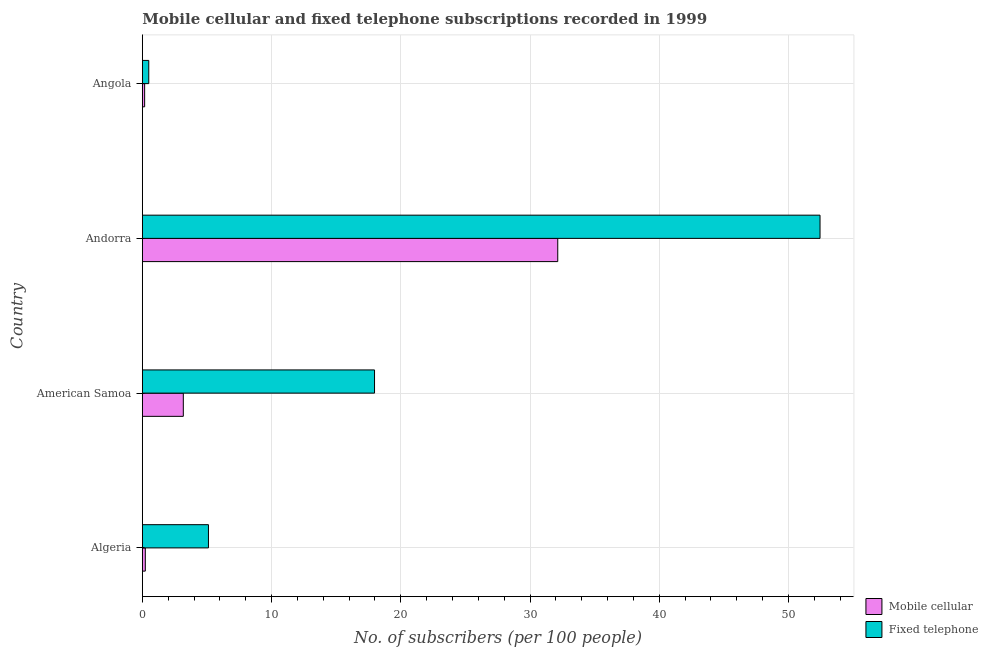How many different coloured bars are there?
Keep it short and to the point. 2. How many groups of bars are there?
Give a very brief answer. 4. Are the number of bars per tick equal to the number of legend labels?
Provide a short and direct response. Yes. Are the number of bars on each tick of the Y-axis equal?
Keep it short and to the point. Yes. How many bars are there on the 3rd tick from the bottom?
Keep it short and to the point. 2. What is the label of the 2nd group of bars from the top?
Ensure brevity in your answer.  Andorra. In how many cases, is the number of bars for a given country not equal to the number of legend labels?
Ensure brevity in your answer.  0. What is the number of mobile cellular subscribers in American Samoa?
Your answer should be very brief. 3.17. Across all countries, what is the maximum number of mobile cellular subscribers?
Your answer should be very brief. 32.15. Across all countries, what is the minimum number of fixed telephone subscribers?
Your answer should be compact. 0.5. In which country was the number of mobile cellular subscribers maximum?
Your answer should be very brief. Andorra. In which country was the number of mobile cellular subscribers minimum?
Provide a succinct answer. Angola. What is the total number of fixed telephone subscribers in the graph?
Offer a terse response. 76.02. What is the difference between the number of mobile cellular subscribers in American Samoa and that in Angola?
Your answer should be compact. 2.99. What is the difference between the number of fixed telephone subscribers in Andorra and the number of mobile cellular subscribers in American Samoa?
Make the answer very short. 49.27. What is the average number of mobile cellular subscribers per country?
Your response must be concise. 8.93. What is the difference between the number of mobile cellular subscribers and number of fixed telephone subscribers in American Samoa?
Keep it short and to the point. -14.8. What is the ratio of the number of fixed telephone subscribers in American Samoa to that in Angola?
Offer a terse response. 36.12. Is the number of mobile cellular subscribers in Algeria less than that in Angola?
Your answer should be compact. No. Is the difference between the number of mobile cellular subscribers in Andorra and Angola greater than the difference between the number of fixed telephone subscribers in Andorra and Angola?
Ensure brevity in your answer.  No. What is the difference between the highest and the second highest number of mobile cellular subscribers?
Provide a succinct answer. 28.98. What is the difference between the highest and the lowest number of mobile cellular subscribers?
Give a very brief answer. 31.97. In how many countries, is the number of mobile cellular subscribers greater than the average number of mobile cellular subscribers taken over all countries?
Keep it short and to the point. 1. What does the 1st bar from the top in Algeria represents?
Your answer should be very brief. Fixed telephone. What does the 1st bar from the bottom in American Samoa represents?
Your response must be concise. Mobile cellular. How many bars are there?
Provide a succinct answer. 8. Are all the bars in the graph horizontal?
Provide a succinct answer. Yes. What is the difference between two consecutive major ticks on the X-axis?
Keep it short and to the point. 10. Where does the legend appear in the graph?
Offer a very short reply. Bottom right. How many legend labels are there?
Provide a short and direct response. 2. How are the legend labels stacked?
Provide a short and direct response. Vertical. What is the title of the graph?
Make the answer very short. Mobile cellular and fixed telephone subscriptions recorded in 1999. What is the label or title of the X-axis?
Offer a terse response. No. of subscribers (per 100 people). What is the label or title of the Y-axis?
Provide a succinct answer. Country. What is the No. of subscribers (per 100 people) in Mobile cellular in Algeria?
Provide a succinct answer. 0.23. What is the No. of subscribers (per 100 people) in Fixed telephone in Algeria?
Provide a succinct answer. 5.12. What is the No. of subscribers (per 100 people) of Mobile cellular in American Samoa?
Your answer should be very brief. 3.17. What is the No. of subscribers (per 100 people) of Fixed telephone in American Samoa?
Provide a succinct answer. 17.97. What is the No. of subscribers (per 100 people) in Mobile cellular in Andorra?
Give a very brief answer. 32.15. What is the No. of subscribers (per 100 people) in Fixed telephone in Andorra?
Provide a short and direct response. 52.44. What is the No. of subscribers (per 100 people) in Mobile cellular in Angola?
Your answer should be compact. 0.18. What is the No. of subscribers (per 100 people) in Fixed telephone in Angola?
Your answer should be compact. 0.5. Across all countries, what is the maximum No. of subscribers (per 100 people) of Mobile cellular?
Your answer should be very brief. 32.15. Across all countries, what is the maximum No. of subscribers (per 100 people) of Fixed telephone?
Provide a succinct answer. 52.44. Across all countries, what is the minimum No. of subscribers (per 100 people) in Mobile cellular?
Offer a very short reply. 0.18. Across all countries, what is the minimum No. of subscribers (per 100 people) of Fixed telephone?
Give a very brief answer. 0.5. What is the total No. of subscribers (per 100 people) of Mobile cellular in the graph?
Keep it short and to the point. 35.72. What is the total No. of subscribers (per 100 people) in Fixed telephone in the graph?
Make the answer very short. 76.02. What is the difference between the No. of subscribers (per 100 people) in Mobile cellular in Algeria and that in American Samoa?
Your answer should be very brief. -2.94. What is the difference between the No. of subscribers (per 100 people) of Fixed telephone in Algeria and that in American Samoa?
Make the answer very short. -12.85. What is the difference between the No. of subscribers (per 100 people) of Mobile cellular in Algeria and that in Andorra?
Your response must be concise. -31.92. What is the difference between the No. of subscribers (per 100 people) in Fixed telephone in Algeria and that in Andorra?
Make the answer very short. -47.33. What is the difference between the No. of subscribers (per 100 people) of Mobile cellular in Algeria and that in Angola?
Provide a short and direct response. 0.05. What is the difference between the No. of subscribers (per 100 people) in Fixed telephone in Algeria and that in Angola?
Provide a short and direct response. 4.62. What is the difference between the No. of subscribers (per 100 people) of Mobile cellular in American Samoa and that in Andorra?
Make the answer very short. -28.97. What is the difference between the No. of subscribers (per 100 people) of Fixed telephone in American Samoa and that in Andorra?
Give a very brief answer. -34.47. What is the difference between the No. of subscribers (per 100 people) in Mobile cellular in American Samoa and that in Angola?
Offer a very short reply. 2.99. What is the difference between the No. of subscribers (per 100 people) in Fixed telephone in American Samoa and that in Angola?
Your answer should be very brief. 17.47. What is the difference between the No. of subscribers (per 100 people) of Mobile cellular in Andorra and that in Angola?
Ensure brevity in your answer.  31.97. What is the difference between the No. of subscribers (per 100 people) of Fixed telephone in Andorra and that in Angola?
Give a very brief answer. 51.94. What is the difference between the No. of subscribers (per 100 people) of Mobile cellular in Algeria and the No. of subscribers (per 100 people) of Fixed telephone in American Samoa?
Give a very brief answer. -17.74. What is the difference between the No. of subscribers (per 100 people) in Mobile cellular in Algeria and the No. of subscribers (per 100 people) in Fixed telephone in Andorra?
Make the answer very short. -52.21. What is the difference between the No. of subscribers (per 100 people) of Mobile cellular in Algeria and the No. of subscribers (per 100 people) of Fixed telephone in Angola?
Offer a terse response. -0.27. What is the difference between the No. of subscribers (per 100 people) of Mobile cellular in American Samoa and the No. of subscribers (per 100 people) of Fixed telephone in Andorra?
Your answer should be compact. -49.27. What is the difference between the No. of subscribers (per 100 people) in Mobile cellular in American Samoa and the No. of subscribers (per 100 people) in Fixed telephone in Angola?
Your answer should be very brief. 2.67. What is the difference between the No. of subscribers (per 100 people) of Mobile cellular in Andorra and the No. of subscribers (per 100 people) of Fixed telephone in Angola?
Ensure brevity in your answer.  31.65. What is the average No. of subscribers (per 100 people) of Mobile cellular per country?
Offer a very short reply. 8.93. What is the average No. of subscribers (per 100 people) of Fixed telephone per country?
Provide a succinct answer. 19.01. What is the difference between the No. of subscribers (per 100 people) of Mobile cellular and No. of subscribers (per 100 people) of Fixed telephone in Algeria?
Your answer should be very brief. -4.89. What is the difference between the No. of subscribers (per 100 people) in Mobile cellular and No. of subscribers (per 100 people) in Fixed telephone in American Samoa?
Offer a terse response. -14.8. What is the difference between the No. of subscribers (per 100 people) of Mobile cellular and No. of subscribers (per 100 people) of Fixed telephone in Andorra?
Keep it short and to the point. -20.3. What is the difference between the No. of subscribers (per 100 people) in Mobile cellular and No. of subscribers (per 100 people) in Fixed telephone in Angola?
Keep it short and to the point. -0.32. What is the ratio of the No. of subscribers (per 100 people) of Mobile cellular in Algeria to that in American Samoa?
Your response must be concise. 0.07. What is the ratio of the No. of subscribers (per 100 people) of Fixed telephone in Algeria to that in American Samoa?
Your answer should be compact. 0.28. What is the ratio of the No. of subscribers (per 100 people) in Mobile cellular in Algeria to that in Andorra?
Your response must be concise. 0.01. What is the ratio of the No. of subscribers (per 100 people) in Fixed telephone in Algeria to that in Andorra?
Give a very brief answer. 0.1. What is the ratio of the No. of subscribers (per 100 people) in Mobile cellular in Algeria to that in Angola?
Give a very brief answer. 1.3. What is the ratio of the No. of subscribers (per 100 people) in Fixed telephone in Algeria to that in Angola?
Provide a short and direct response. 10.29. What is the ratio of the No. of subscribers (per 100 people) of Mobile cellular in American Samoa to that in Andorra?
Provide a succinct answer. 0.1. What is the ratio of the No. of subscribers (per 100 people) of Fixed telephone in American Samoa to that in Andorra?
Ensure brevity in your answer.  0.34. What is the ratio of the No. of subscribers (per 100 people) in Mobile cellular in American Samoa to that in Angola?
Give a very brief answer. 17.85. What is the ratio of the No. of subscribers (per 100 people) in Fixed telephone in American Samoa to that in Angola?
Your answer should be very brief. 36.12. What is the ratio of the No. of subscribers (per 100 people) in Mobile cellular in Andorra to that in Angola?
Your response must be concise. 180.96. What is the ratio of the No. of subscribers (per 100 people) in Fixed telephone in Andorra to that in Angola?
Your answer should be very brief. 105.44. What is the difference between the highest and the second highest No. of subscribers (per 100 people) of Mobile cellular?
Your answer should be compact. 28.97. What is the difference between the highest and the second highest No. of subscribers (per 100 people) of Fixed telephone?
Ensure brevity in your answer.  34.47. What is the difference between the highest and the lowest No. of subscribers (per 100 people) of Mobile cellular?
Give a very brief answer. 31.97. What is the difference between the highest and the lowest No. of subscribers (per 100 people) in Fixed telephone?
Offer a very short reply. 51.94. 